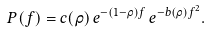<formula> <loc_0><loc_0><loc_500><loc_500>P ( f ) = c ( \rho ) \, e ^ { - ( 1 - \rho ) f } \, e ^ { - b ( \rho ) f ^ { 2 } } .</formula> 